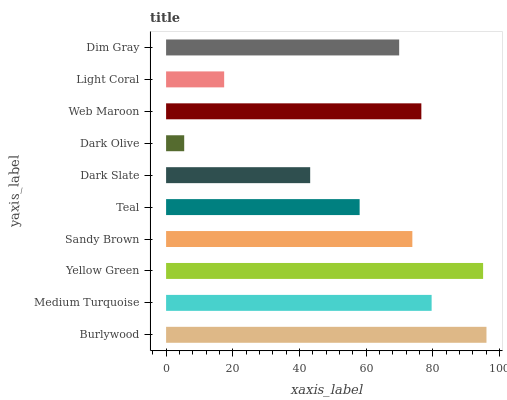Is Dark Olive the minimum?
Answer yes or no. Yes. Is Burlywood the maximum?
Answer yes or no. Yes. Is Medium Turquoise the minimum?
Answer yes or no. No. Is Medium Turquoise the maximum?
Answer yes or no. No. Is Burlywood greater than Medium Turquoise?
Answer yes or no. Yes. Is Medium Turquoise less than Burlywood?
Answer yes or no. Yes. Is Medium Turquoise greater than Burlywood?
Answer yes or no. No. Is Burlywood less than Medium Turquoise?
Answer yes or no. No. Is Sandy Brown the high median?
Answer yes or no. Yes. Is Dim Gray the low median?
Answer yes or no. Yes. Is Teal the high median?
Answer yes or no. No. Is Dark Slate the low median?
Answer yes or no. No. 